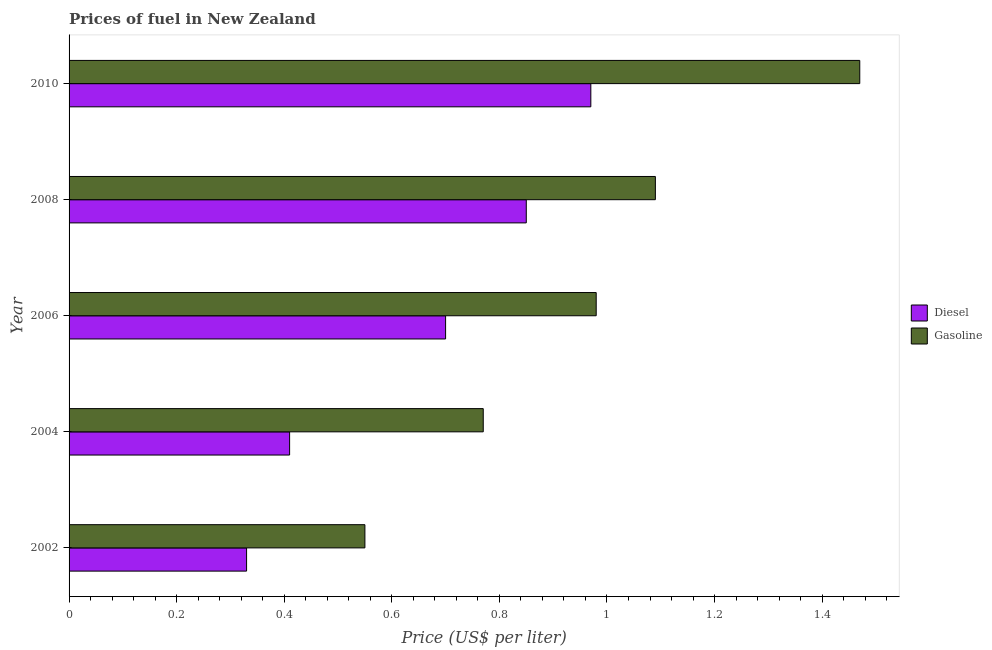How many different coloured bars are there?
Offer a very short reply. 2. Are the number of bars on each tick of the Y-axis equal?
Make the answer very short. Yes. What is the label of the 5th group of bars from the top?
Give a very brief answer. 2002. What is the diesel price in 2004?
Your answer should be compact. 0.41. Across all years, what is the maximum diesel price?
Provide a succinct answer. 0.97. Across all years, what is the minimum diesel price?
Keep it short and to the point. 0.33. What is the total diesel price in the graph?
Your answer should be compact. 3.26. What is the difference between the gasoline price in 2004 and that in 2006?
Give a very brief answer. -0.21. What is the difference between the diesel price in 2006 and the gasoline price in 2002?
Your answer should be compact. 0.15. What is the average gasoline price per year?
Provide a succinct answer. 0.97. In the year 2006, what is the difference between the diesel price and gasoline price?
Offer a very short reply. -0.28. In how many years, is the gasoline price greater than 0.7600000000000001 US$ per litre?
Your answer should be very brief. 4. What is the ratio of the gasoline price in 2002 to that in 2004?
Keep it short and to the point. 0.71. What is the difference between the highest and the second highest gasoline price?
Give a very brief answer. 0.38. What is the difference between the highest and the lowest diesel price?
Your answer should be very brief. 0.64. Is the sum of the gasoline price in 2006 and 2010 greater than the maximum diesel price across all years?
Keep it short and to the point. Yes. What does the 2nd bar from the top in 2002 represents?
Give a very brief answer. Diesel. What does the 2nd bar from the bottom in 2006 represents?
Offer a very short reply. Gasoline. How many bars are there?
Your answer should be compact. 10. How many years are there in the graph?
Your answer should be compact. 5. What is the difference between two consecutive major ticks on the X-axis?
Your answer should be very brief. 0.2. Does the graph contain grids?
Your answer should be compact. No. How many legend labels are there?
Offer a very short reply. 2. How are the legend labels stacked?
Your answer should be very brief. Vertical. What is the title of the graph?
Your answer should be compact. Prices of fuel in New Zealand. What is the label or title of the X-axis?
Offer a terse response. Price (US$ per liter). What is the Price (US$ per liter) of Diesel in 2002?
Make the answer very short. 0.33. What is the Price (US$ per liter) in Gasoline in 2002?
Offer a terse response. 0.55. What is the Price (US$ per liter) of Diesel in 2004?
Provide a succinct answer. 0.41. What is the Price (US$ per liter) in Gasoline in 2004?
Make the answer very short. 0.77. What is the Price (US$ per liter) of Diesel in 2006?
Offer a very short reply. 0.7. What is the Price (US$ per liter) of Diesel in 2008?
Provide a short and direct response. 0.85. What is the Price (US$ per liter) in Gasoline in 2008?
Your answer should be compact. 1.09. What is the Price (US$ per liter) of Diesel in 2010?
Ensure brevity in your answer.  0.97. What is the Price (US$ per liter) in Gasoline in 2010?
Your answer should be very brief. 1.47. Across all years, what is the maximum Price (US$ per liter) in Diesel?
Offer a very short reply. 0.97. Across all years, what is the maximum Price (US$ per liter) of Gasoline?
Make the answer very short. 1.47. Across all years, what is the minimum Price (US$ per liter) of Diesel?
Give a very brief answer. 0.33. Across all years, what is the minimum Price (US$ per liter) in Gasoline?
Your response must be concise. 0.55. What is the total Price (US$ per liter) of Diesel in the graph?
Your answer should be compact. 3.26. What is the total Price (US$ per liter) in Gasoline in the graph?
Make the answer very short. 4.86. What is the difference between the Price (US$ per liter) in Diesel in 2002 and that in 2004?
Ensure brevity in your answer.  -0.08. What is the difference between the Price (US$ per liter) of Gasoline in 2002 and that in 2004?
Your answer should be compact. -0.22. What is the difference between the Price (US$ per liter) in Diesel in 2002 and that in 2006?
Your answer should be compact. -0.37. What is the difference between the Price (US$ per liter) in Gasoline in 2002 and that in 2006?
Offer a terse response. -0.43. What is the difference between the Price (US$ per liter) in Diesel in 2002 and that in 2008?
Provide a succinct answer. -0.52. What is the difference between the Price (US$ per liter) in Gasoline in 2002 and that in 2008?
Your response must be concise. -0.54. What is the difference between the Price (US$ per liter) in Diesel in 2002 and that in 2010?
Your answer should be compact. -0.64. What is the difference between the Price (US$ per liter) in Gasoline in 2002 and that in 2010?
Provide a succinct answer. -0.92. What is the difference between the Price (US$ per liter) of Diesel in 2004 and that in 2006?
Your answer should be very brief. -0.29. What is the difference between the Price (US$ per liter) of Gasoline in 2004 and that in 2006?
Make the answer very short. -0.21. What is the difference between the Price (US$ per liter) of Diesel in 2004 and that in 2008?
Provide a succinct answer. -0.44. What is the difference between the Price (US$ per liter) of Gasoline in 2004 and that in 2008?
Offer a very short reply. -0.32. What is the difference between the Price (US$ per liter) of Diesel in 2004 and that in 2010?
Offer a very short reply. -0.56. What is the difference between the Price (US$ per liter) in Gasoline in 2004 and that in 2010?
Your response must be concise. -0.7. What is the difference between the Price (US$ per liter) of Diesel in 2006 and that in 2008?
Your answer should be very brief. -0.15. What is the difference between the Price (US$ per liter) in Gasoline in 2006 and that in 2008?
Your response must be concise. -0.11. What is the difference between the Price (US$ per liter) of Diesel in 2006 and that in 2010?
Provide a succinct answer. -0.27. What is the difference between the Price (US$ per liter) in Gasoline in 2006 and that in 2010?
Provide a short and direct response. -0.49. What is the difference between the Price (US$ per liter) in Diesel in 2008 and that in 2010?
Offer a terse response. -0.12. What is the difference between the Price (US$ per liter) in Gasoline in 2008 and that in 2010?
Your response must be concise. -0.38. What is the difference between the Price (US$ per liter) in Diesel in 2002 and the Price (US$ per liter) in Gasoline in 2004?
Your response must be concise. -0.44. What is the difference between the Price (US$ per liter) of Diesel in 2002 and the Price (US$ per liter) of Gasoline in 2006?
Your response must be concise. -0.65. What is the difference between the Price (US$ per liter) in Diesel in 2002 and the Price (US$ per liter) in Gasoline in 2008?
Your answer should be very brief. -0.76. What is the difference between the Price (US$ per liter) of Diesel in 2002 and the Price (US$ per liter) of Gasoline in 2010?
Ensure brevity in your answer.  -1.14. What is the difference between the Price (US$ per liter) in Diesel in 2004 and the Price (US$ per liter) in Gasoline in 2006?
Your answer should be compact. -0.57. What is the difference between the Price (US$ per liter) of Diesel in 2004 and the Price (US$ per liter) of Gasoline in 2008?
Give a very brief answer. -0.68. What is the difference between the Price (US$ per liter) in Diesel in 2004 and the Price (US$ per liter) in Gasoline in 2010?
Provide a short and direct response. -1.06. What is the difference between the Price (US$ per liter) in Diesel in 2006 and the Price (US$ per liter) in Gasoline in 2008?
Provide a short and direct response. -0.39. What is the difference between the Price (US$ per liter) in Diesel in 2006 and the Price (US$ per liter) in Gasoline in 2010?
Give a very brief answer. -0.77. What is the difference between the Price (US$ per liter) in Diesel in 2008 and the Price (US$ per liter) in Gasoline in 2010?
Keep it short and to the point. -0.62. What is the average Price (US$ per liter) of Diesel per year?
Give a very brief answer. 0.65. What is the average Price (US$ per liter) in Gasoline per year?
Your answer should be compact. 0.97. In the year 2002, what is the difference between the Price (US$ per liter) in Diesel and Price (US$ per liter) in Gasoline?
Make the answer very short. -0.22. In the year 2004, what is the difference between the Price (US$ per liter) in Diesel and Price (US$ per liter) in Gasoline?
Your answer should be very brief. -0.36. In the year 2006, what is the difference between the Price (US$ per liter) in Diesel and Price (US$ per liter) in Gasoline?
Keep it short and to the point. -0.28. In the year 2008, what is the difference between the Price (US$ per liter) of Diesel and Price (US$ per liter) of Gasoline?
Offer a terse response. -0.24. What is the ratio of the Price (US$ per liter) in Diesel in 2002 to that in 2004?
Make the answer very short. 0.8. What is the ratio of the Price (US$ per liter) of Gasoline in 2002 to that in 2004?
Offer a very short reply. 0.71. What is the ratio of the Price (US$ per liter) in Diesel in 2002 to that in 2006?
Give a very brief answer. 0.47. What is the ratio of the Price (US$ per liter) of Gasoline in 2002 to that in 2006?
Your response must be concise. 0.56. What is the ratio of the Price (US$ per liter) of Diesel in 2002 to that in 2008?
Offer a terse response. 0.39. What is the ratio of the Price (US$ per liter) of Gasoline in 2002 to that in 2008?
Ensure brevity in your answer.  0.5. What is the ratio of the Price (US$ per liter) of Diesel in 2002 to that in 2010?
Offer a terse response. 0.34. What is the ratio of the Price (US$ per liter) in Gasoline in 2002 to that in 2010?
Ensure brevity in your answer.  0.37. What is the ratio of the Price (US$ per liter) of Diesel in 2004 to that in 2006?
Offer a terse response. 0.59. What is the ratio of the Price (US$ per liter) of Gasoline in 2004 to that in 2006?
Ensure brevity in your answer.  0.79. What is the ratio of the Price (US$ per liter) in Diesel in 2004 to that in 2008?
Provide a short and direct response. 0.48. What is the ratio of the Price (US$ per liter) in Gasoline in 2004 to that in 2008?
Give a very brief answer. 0.71. What is the ratio of the Price (US$ per liter) in Diesel in 2004 to that in 2010?
Make the answer very short. 0.42. What is the ratio of the Price (US$ per liter) in Gasoline in 2004 to that in 2010?
Your answer should be compact. 0.52. What is the ratio of the Price (US$ per liter) of Diesel in 2006 to that in 2008?
Offer a very short reply. 0.82. What is the ratio of the Price (US$ per liter) in Gasoline in 2006 to that in 2008?
Keep it short and to the point. 0.9. What is the ratio of the Price (US$ per liter) of Diesel in 2006 to that in 2010?
Offer a very short reply. 0.72. What is the ratio of the Price (US$ per liter) in Gasoline in 2006 to that in 2010?
Your answer should be compact. 0.67. What is the ratio of the Price (US$ per liter) of Diesel in 2008 to that in 2010?
Keep it short and to the point. 0.88. What is the ratio of the Price (US$ per liter) in Gasoline in 2008 to that in 2010?
Your answer should be compact. 0.74. What is the difference between the highest and the second highest Price (US$ per liter) in Diesel?
Your answer should be compact. 0.12. What is the difference between the highest and the second highest Price (US$ per liter) in Gasoline?
Ensure brevity in your answer.  0.38. What is the difference between the highest and the lowest Price (US$ per liter) in Diesel?
Make the answer very short. 0.64. 